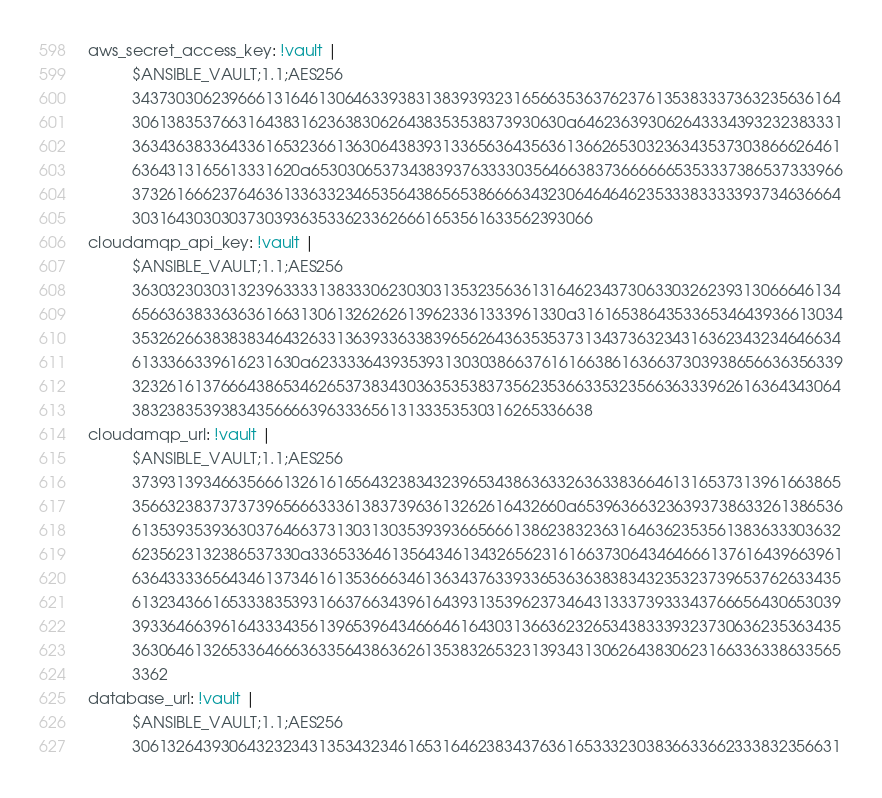<code> <loc_0><loc_0><loc_500><loc_500><_YAML_>aws_secret_access_key: !vault |
          $ANSIBLE_VAULT;1.1;AES256
          34373030623966613164613064633938313839393231656635363762376135383337363235636164
          3061383537663164383162363830626438353538373930630a646236393062643334393232383331
          36343638336433616532366136306438393133656364356361366265303236343537303866626461
          6364313165613331620a653030653734383937633330356466383736666665353337386537333966
          37326166623764636133633234653564386565386666343230646464623533383333393734636664
          3031643030303730393635336233626661653561633562393066
cloudamqp_api_key: !vault |
          $ANSIBLE_VAULT;1.1;AES256
          36303230303132396333313833306230303135323563613164623437306330326239313066646134
          6566363833636361663130613262626139623361333961330a316165386435336534643936613034
          35326266383838346432633136393363383965626436353537313437363234316362343234646634
          6133366339616231630a623333643935393130303866376161663861636637303938656636356339
          32326161376664386534626537383430363535383735623536633532356636333962616364343064
          3832383539383435666639633365613133353530316265336638
cloudamqp_url: !vault |
          $ANSIBLE_VAULT;1.1;AES256
          37393139346635666132616165643238343239653438636332636338366461316537313961663865
          3566323837373739656663336138373963613262616432660a653963663236393738633261386536
          61353935393630376466373130313035393936656661386238323631646362353561383633303632
          6235623132386537330a336533646135643461343265623161663730643464666137616439663961
          63643333656434613734616135366634613634376339336536363838343235323739653762633435
          61323436616533383539316637663439616439313539623734643133373933343766656430653039
          39336466396164333435613965396434666461643031366362326534383339323730636235363435
          36306461326533646663633564386362613538326532313934313062643830623166336338633565
          3362
database_url: !vault |
          $ANSIBLE_VAULT;1.1;AES256
          30613264393064323234313534323461653164623834376361653332303836633662333832356631</code> 